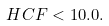Convert formula to latex. <formula><loc_0><loc_0><loc_500><loc_500>H C F < 1 0 . 0 .</formula> 